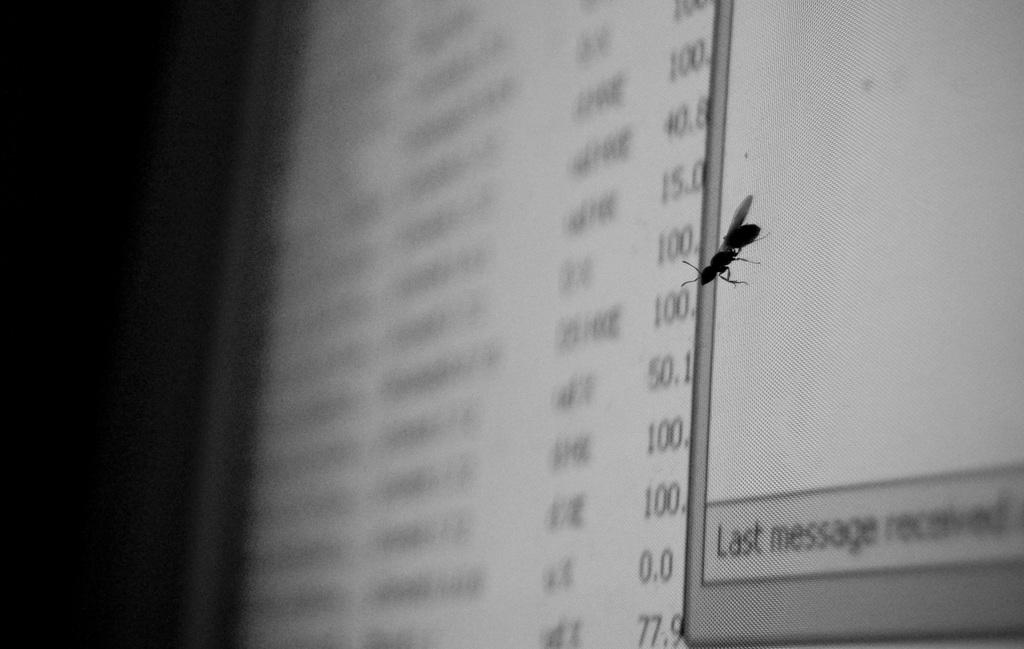What is the main object in the image? There is a screen in the image. What is present on the screen? There is an insect on the screen. What type of minister is standing next to the insect on the screen? There is no minister present in the image; it only features a screen with an insect on it. 